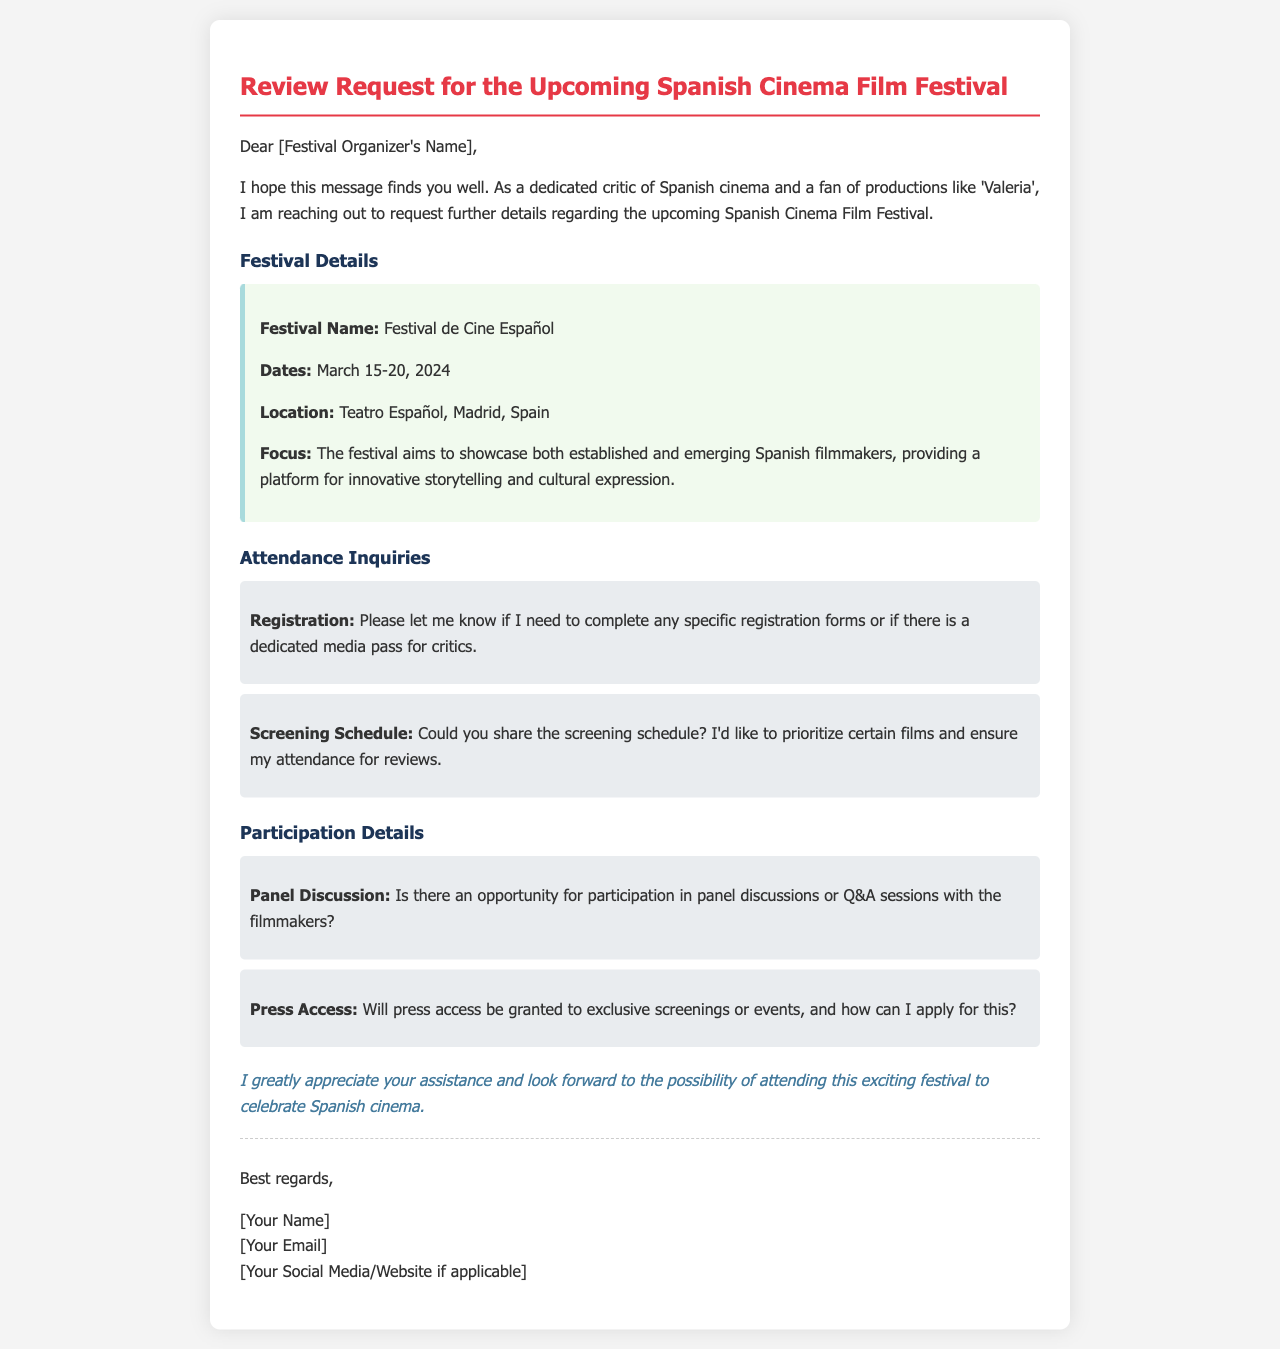What is the name of the festival? The festival is explicitly named "Festival de Cine Español" in the document.
Answer: Festival de Cine Español What are the dates of the festival? The document states the festival dates as March 15-20, 2024.
Answer: March 15-20, 2024 Where is the festival located? The location mentioned in the document is "Teatro Español, Madrid, Spain."
Answer: Teatro Español, Madrid, Spain What is the main focus of the festival? The focus of the festival is to showcase both established and emerging Spanish filmmakers, as stated in the document.
Answer: Showcase established and emerging Spanish filmmakers Is there a specific registration process mentioned? The inquiry section asks if any specific registration forms are needed for media attendance.
Answer: Yes What opportunities for participation with filmmakers are mentioned? The document inquires about participation in panel discussions or Q&A sessions with filmmakers.
Answer: Panel discussions or Q&A sessions Will there be press access to exclusive screenings? The document asks about press access to exclusive screenings or events.
Answer: Yes What is the tone of the conclusion? The conclusion expresses gratitude and eagerness to attend the festival.
Answer: Gratitude and eagerness What does the author express interest in attending? The author is interested in attending the festival to celebrate Spanish cinema.
Answer: Celebrate Spanish cinema 